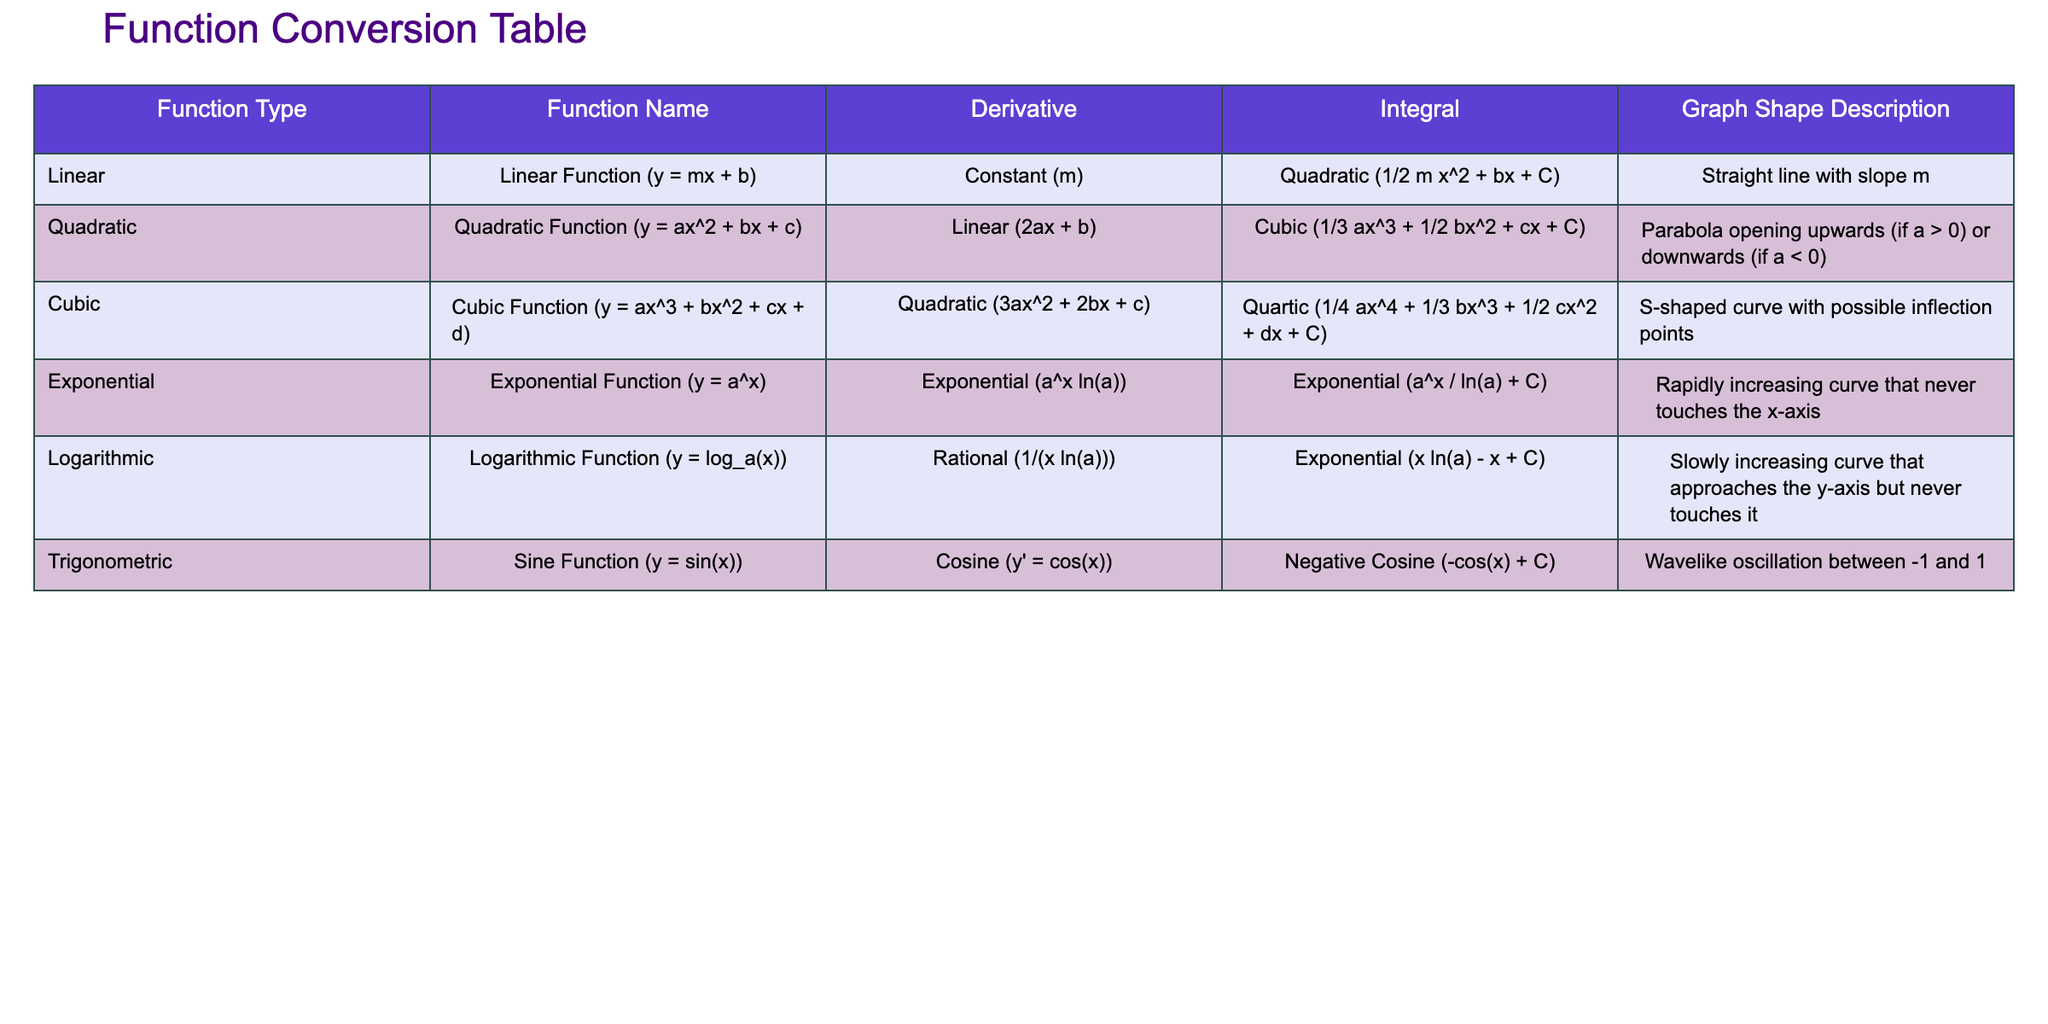What is the derivative of the quadratic function? The derivative of the quadratic function (y = ax^2 + bx + c) is listed in the table as "Linear (2ax + b)."
Answer: Linear (2ax + b) Which function type has an integral that is a quartic function? According to the table, the cubic function's integral is a quartic function (1/4 ax^4 + 1/3 bx^3 + 1/2 cx^2 + dx + C).
Answer: Cubic True or False: The integral of the linear function is a cubic function. The table indicates that the integral of the linear function (y = mx + b) is a quadratic function (1/2 m x^2 + bx + C), which means the statement is false.
Answer: False What is the graph shape description for the exponential function? The table identifies the graph shape of the exponential function (y = a^x) as a "Rapidly increasing curve that never touches the x-axis."
Answer: Rapidly increasing curve that never touches the x-axis If the coefficient 'a' in the quadratic function is negative, what shape does its graph take? The table states that if 'a' is less than zero in the quadratic function (y = ax^2 + bx + c), the graph opens downwards, thus forming a parabola that opens downwards.
Answer: Opens downwards (parabola) What is the combined sum of the derivatives of the linear and quadratic functions? The derivative of the linear function is "Constant (m)" and the derivative of the quadratic function is "Linear (2ax + b)." If we consider these as representing types of functions and not numerical values, they cannot be summed directly since they are different types of functions. Therefore, a numerical sum is not applicable.
Answer: Not applicable Which function type has a derivative that includes a cube term? The table shows that the cubic function derivative is "Quadratic (3ax^2 + 2bx + c)," which is quadratic and does not have a cube term. Therefore, no function type in this table has a derivative with a cube term.
Answer: None True or False: The derivative of the sine function is a constant function. The table provides that the derivative of the sine function (y = sin(x)) is the cosine function (y' = cos(x)), which is not constant. This means the statement is false.
Answer: False What type of graph does the sine function have? The table describes the graph shape of the sine function (y = sin(x)) as a "Wavelike oscillation between -1 and 1."
Answer: Wavelike oscillation between -1 and 1 